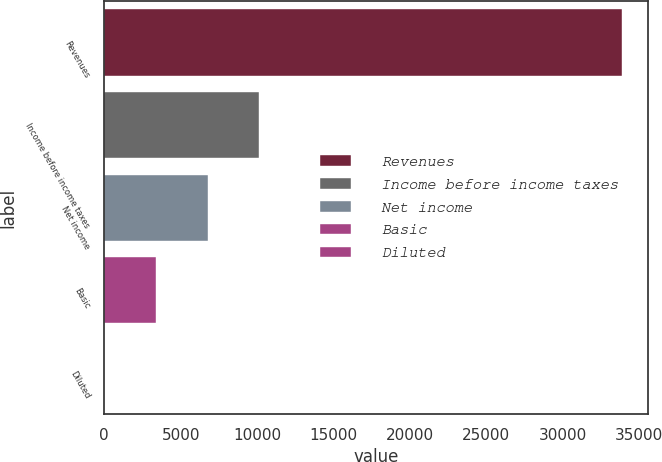Convert chart to OTSL. <chart><loc_0><loc_0><loc_500><loc_500><bar_chart><fcel>Revenues<fcel>Income before income taxes<fcel>Net income<fcel>Basic<fcel>Diluted<nl><fcel>33858<fcel>10157.7<fcel>6771.92<fcel>3386.16<fcel>0.4<nl></chart> 